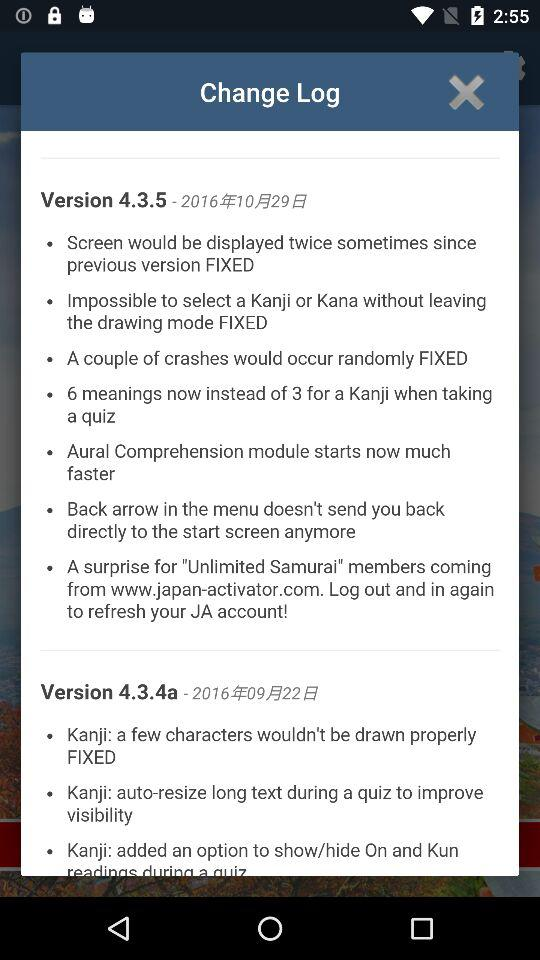What is the latest version of this application used? The latest version is 4.3.5. 